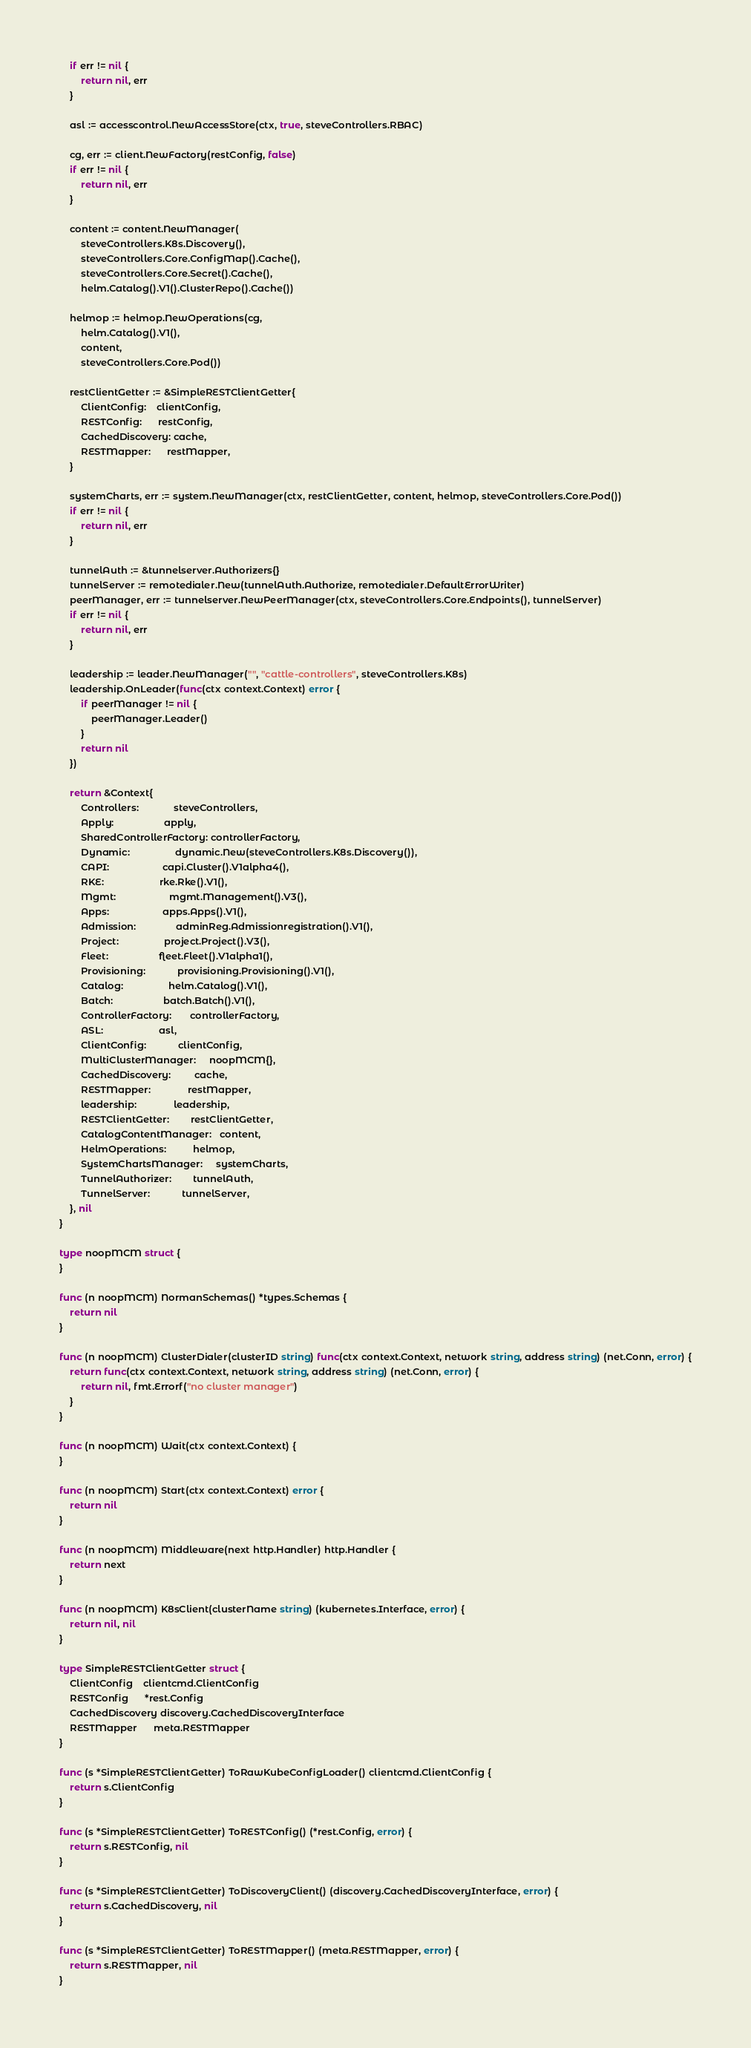<code> <loc_0><loc_0><loc_500><loc_500><_Go_>	if err != nil {
		return nil, err
	}

	asl := accesscontrol.NewAccessStore(ctx, true, steveControllers.RBAC)

	cg, err := client.NewFactory(restConfig, false)
	if err != nil {
		return nil, err
	}

	content := content.NewManager(
		steveControllers.K8s.Discovery(),
		steveControllers.Core.ConfigMap().Cache(),
		steveControllers.Core.Secret().Cache(),
		helm.Catalog().V1().ClusterRepo().Cache())

	helmop := helmop.NewOperations(cg,
		helm.Catalog().V1(),
		content,
		steveControllers.Core.Pod())

	restClientGetter := &SimpleRESTClientGetter{
		ClientConfig:    clientConfig,
		RESTConfig:      restConfig,
		CachedDiscovery: cache,
		RESTMapper:      restMapper,
	}

	systemCharts, err := system.NewManager(ctx, restClientGetter, content, helmop, steveControllers.Core.Pod())
	if err != nil {
		return nil, err
	}

	tunnelAuth := &tunnelserver.Authorizers{}
	tunnelServer := remotedialer.New(tunnelAuth.Authorize, remotedialer.DefaultErrorWriter)
	peerManager, err := tunnelserver.NewPeerManager(ctx, steveControllers.Core.Endpoints(), tunnelServer)
	if err != nil {
		return nil, err
	}

	leadership := leader.NewManager("", "cattle-controllers", steveControllers.K8s)
	leadership.OnLeader(func(ctx context.Context) error {
		if peerManager != nil {
			peerManager.Leader()
		}
		return nil
	})

	return &Context{
		Controllers:             steveControllers,
		Apply:                   apply,
		SharedControllerFactory: controllerFactory,
		Dynamic:                 dynamic.New(steveControllers.K8s.Discovery()),
		CAPI:                    capi.Cluster().V1alpha4(),
		RKE:                     rke.Rke().V1(),
		Mgmt:                    mgmt.Management().V3(),
		Apps:                    apps.Apps().V1(),
		Admission:               adminReg.Admissionregistration().V1(),
		Project:                 project.Project().V3(),
		Fleet:                   fleet.Fleet().V1alpha1(),
		Provisioning:            provisioning.Provisioning().V1(),
		Catalog:                 helm.Catalog().V1(),
		Batch:                   batch.Batch().V1(),
		ControllerFactory:       controllerFactory,
		ASL:                     asl,
		ClientConfig:            clientConfig,
		MultiClusterManager:     noopMCM{},
		CachedDiscovery:         cache,
		RESTMapper:              restMapper,
		leadership:              leadership,
		RESTClientGetter:        restClientGetter,
		CatalogContentManager:   content,
		HelmOperations:          helmop,
		SystemChartsManager:     systemCharts,
		TunnelAuthorizer:        tunnelAuth,
		TunnelServer:            tunnelServer,
	}, nil
}

type noopMCM struct {
}

func (n noopMCM) NormanSchemas() *types.Schemas {
	return nil
}

func (n noopMCM) ClusterDialer(clusterID string) func(ctx context.Context, network string, address string) (net.Conn, error) {
	return func(ctx context.Context, network string, address string) (net.Conn, error) {
		return nil, fmt.Errorf("no cluster manager")
	}
}

func (n noopMCM) Wait(ctx context.Context) {
}

func (n noopMCM) Start(ctx context.Context) error {
	return nil
}

func (n noopMCM) Middleware(next http.Handler) http.Handler {
	return next
}

func (n noopMCM) K8sClient(clusterName string) (kubernetes.Interface, error) {
	return nil, nil
}

type SimpleRESTClientGetter struct {
	ClientConfig    clientcmd.ClientConfig
	RESTConfig      *rest.Config
	CachedDiscovery discovery.CachedDiscoveryInterface
	RESTMapper      meta.RESTMapper
}

func (s *SimpleRESTClientGetter) ToRawKubeConfigLoader() clientcmd.ClientConfig {
	return s.ClientConfig
}

func (s *SimpleRESTClientGetter) ToRESTConfig() (*rest.Config, error) {
	return s.RESTConfig, nil
}

func (s *SimpleRESTClientGetter) ToDiscoveryClient() (discovery.CachedDiscoveryInterface, error) {
	return s.CachedDiscovery, nil
}

func (s *SimpleRESTClientGetter) ToRESTMapper() (meta.RESTMapper, error) {
	return s.RESTMapper, nil
}
</code> 